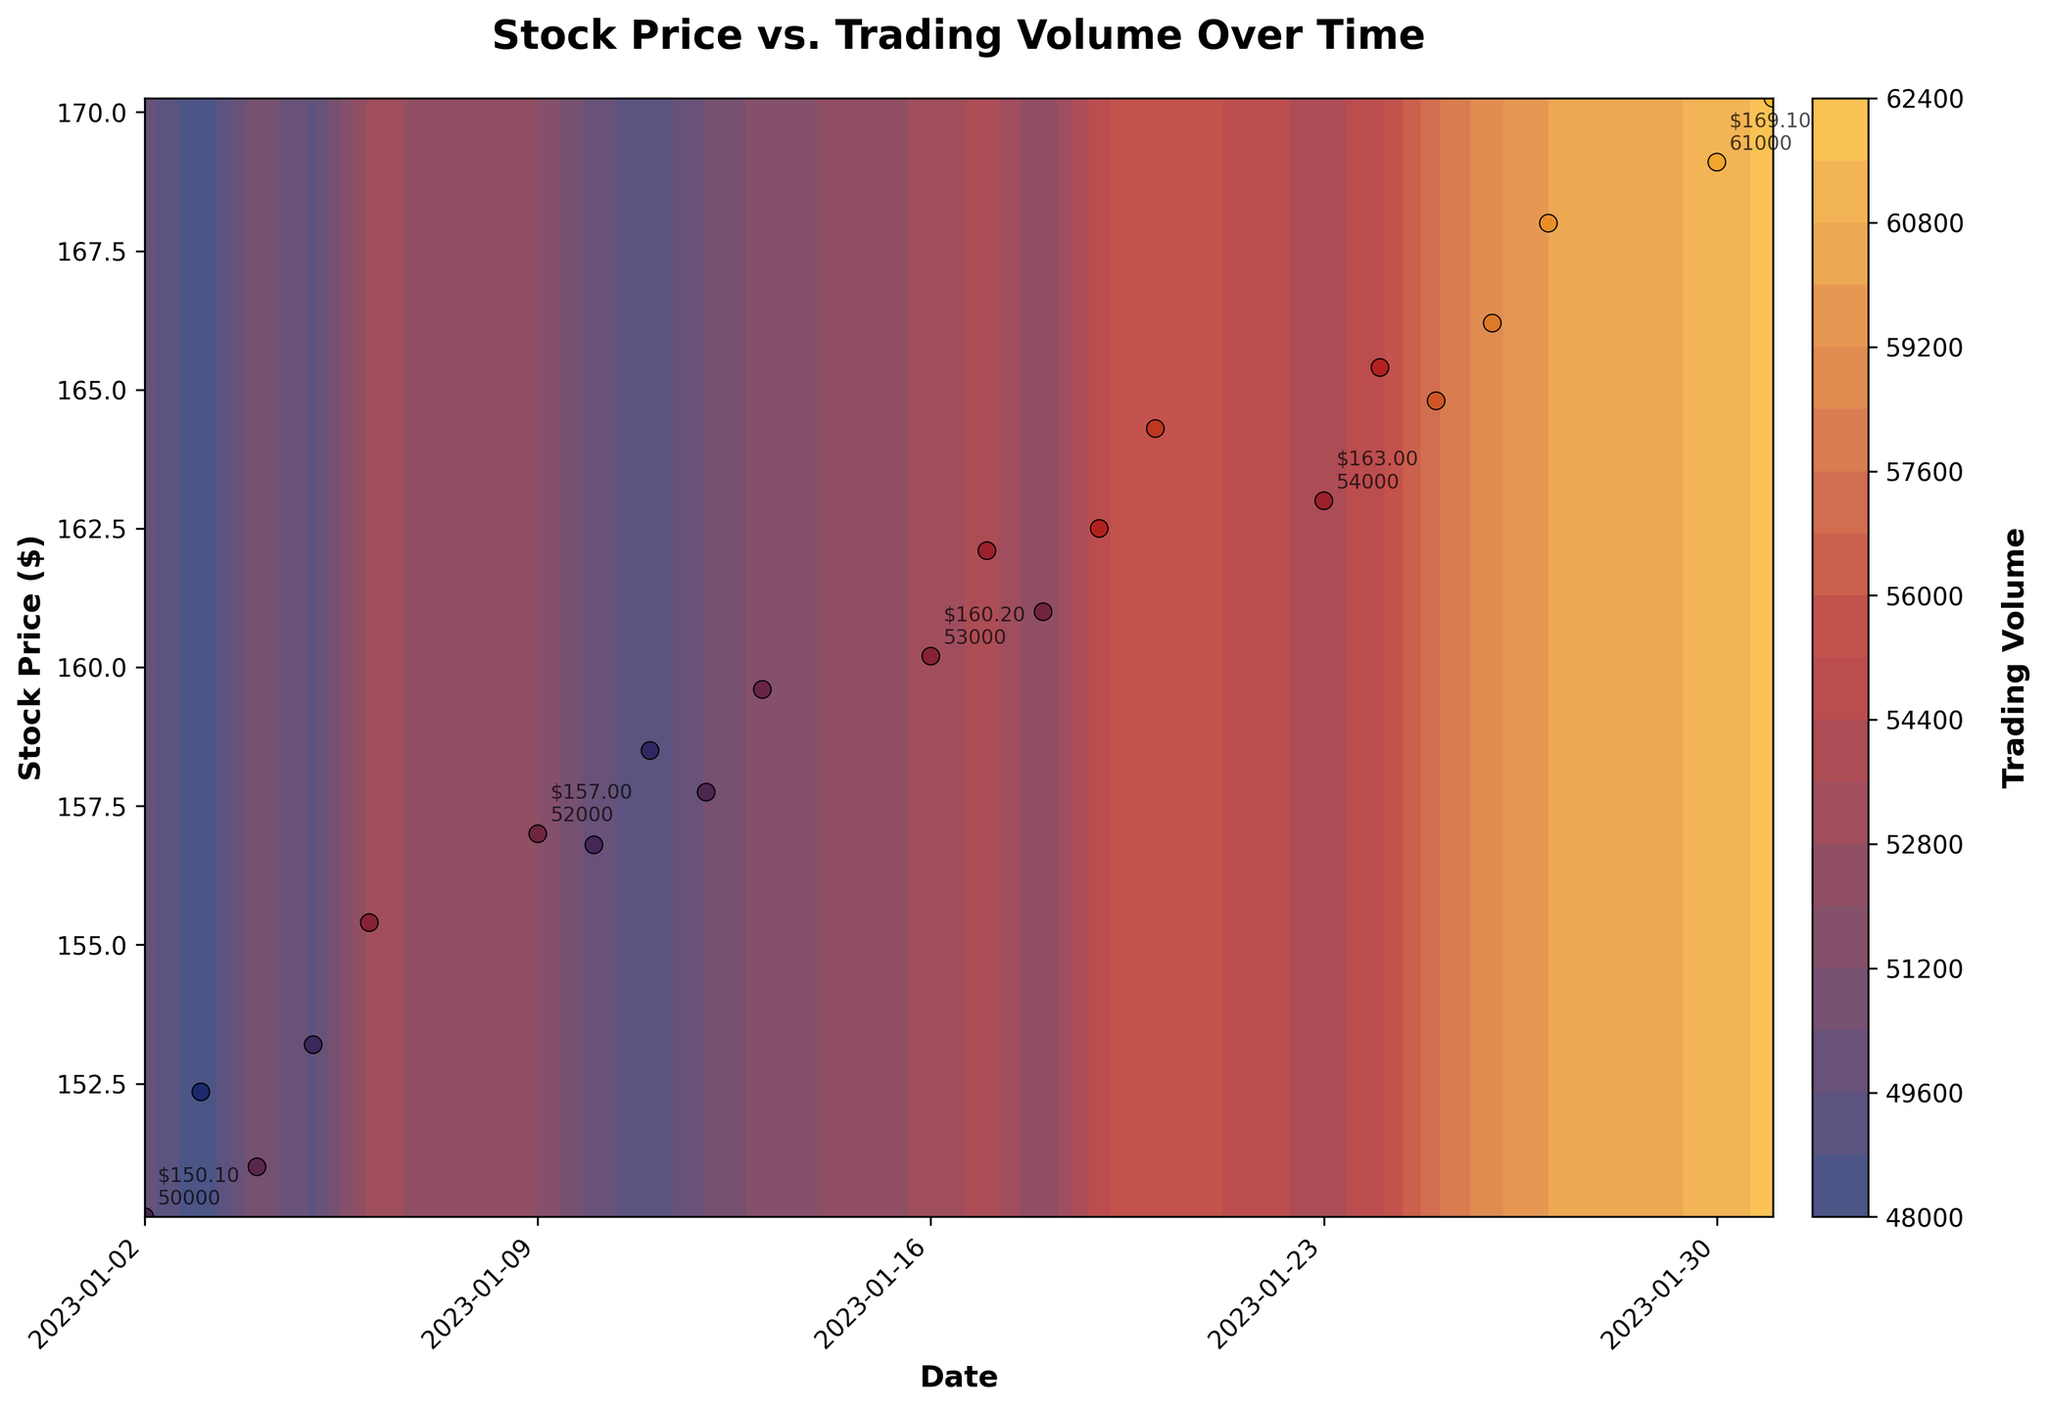What is the title of the plot? The title is displayed prominently at the top center of the plot, making it easy to identify.
Answer: Stock Price vs. Trading Volume Over Time Which axes represent the stock price and the volume, respectively? The y-axis, labeled "Stock Price ($)", represents the stock price, and the color bar, labeled "Trading Volume", represents the volume.
Answer: y-axis and color bar What is the date range shown on the x-axis of the plot? The x-axis represents the dates, starting from "2023-01-02" and ending on "2023-01-31". These dates can be read directly from the x-axis labels.
Answer: 2023-01-02 to 2023-01-31 What is the highest stock price recorded in the figure, and on what date did it occur? Look at the y-axis for the highest stock price value and find the annotation closest to the peak, which corresponds to "2023-01-31" with a stock price of "$170.25".
Answer: $170.25 on 2023-01-31 Which date had the minimum trading volume, and what was the corresponding stock price? Identify the smallest trading volume by comparing the color gradient and refer to the scatter plot for its corresponding data points. The minimum trading volume is 48000 on "2023-01-03" with a stock price of "$152.35".
Answer: 2023-01-03, $152.35 What pattern is observed between trading volume and stock price as time progresses? Observing the color gradient and scatter plot, it is clear that as time progresses, both the stock price and trading volume generally increase. Higher stock prices and volumes are closer to the later dates on the right side of the plot.
Answer: Both increase over time How does the trading volume on January 20, 2023, compare to that on January 31, 2023? Compare the colors of the annotations for these two dates. January 20 shows a trading volume of 56000, while January 31 shows a trading volume of 62000, indicating an increase.
Answer: January 31 has higher volume What is the average stock price for the data points annotated on the plot? Calculate the stock price for every 5th data point annotated: ($150.10 + $153.20 + $158.50 + $162.50 + $168.00) / 5 = $158.46.
Answer: $158.46 Are there any annotations or points where the stock price decreases while the trading volume increases? By analyzing the annotations, there is no clear indication where the stock price decreases and the trading volume increases. All annotations show an upward trend in both parameters.
Answer: No What does the color gradient in the contour plot represent? The color gradient represents the trading volume, with different shades indicating varying levels of volume.
Answer: Trading Volume 